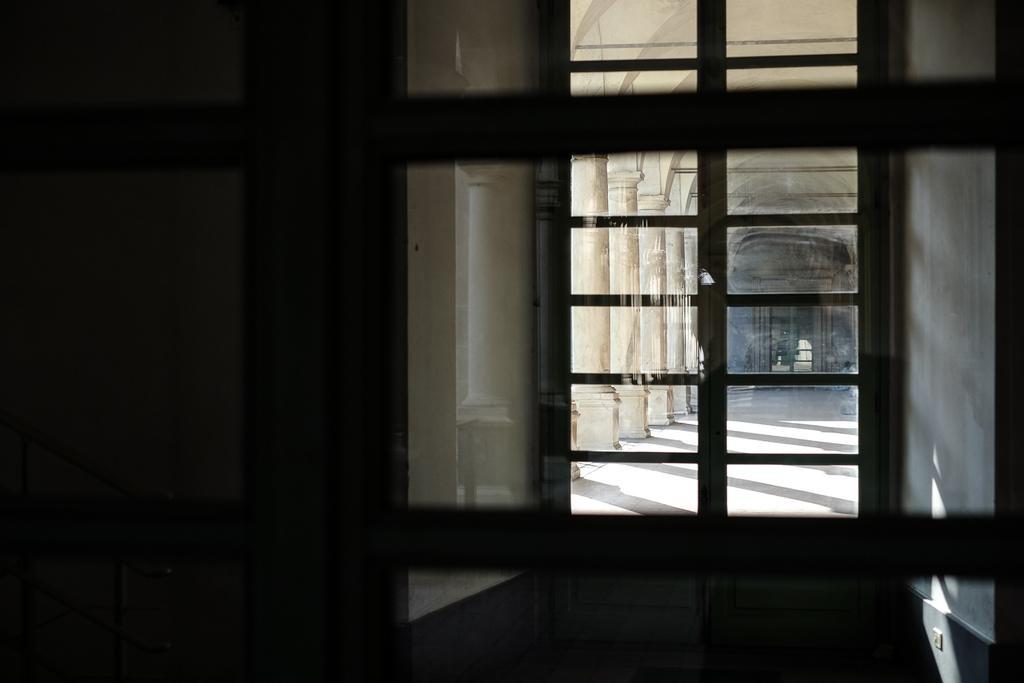Please provide a concise description of this image. In this image I can see the view of building from the glass door. 